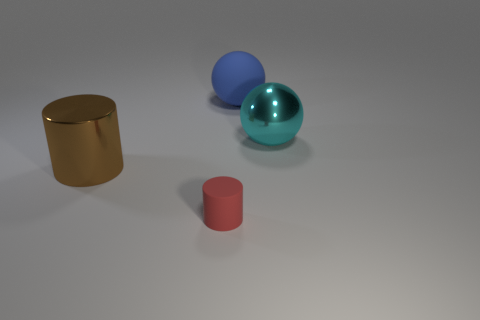How many small cylinders are the same material as the brown thing? Examining the image, there appears to be only one object that might be described as a 'brown thing', which is a shiny, golden-colored cylinder. Since there are no other small cylinders visible that share this glossy, metallic texture, the answer is none. Therefore, there are no small cylinders made of the same material as the golden cylinder in the image. 